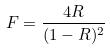<formula> <loc_0><loc_0><loc_500><loc_500>F = \frac { 4 R } { ( 1 - R ) ^ { 2 } }</formula> 